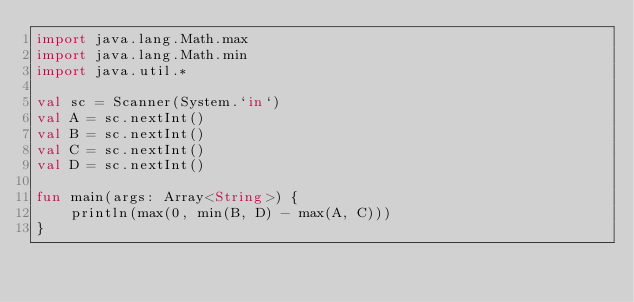Convert code to text. <code><loc_0><loc_0><loc_500><loc_500><_Kotlin_>import java.lang.Math.max
import java.lang.Math.min
import java.util.*

val sc = Scanner(System.`in`)
val A = sc.nextInt()
val B = sc.nextInt()
val C = sc.nextInt()
val D = sc.nextInt()

fun main(args: Array<String>) {
    println(max(0, min(B, D) - max(A, C)))
}
</code> 